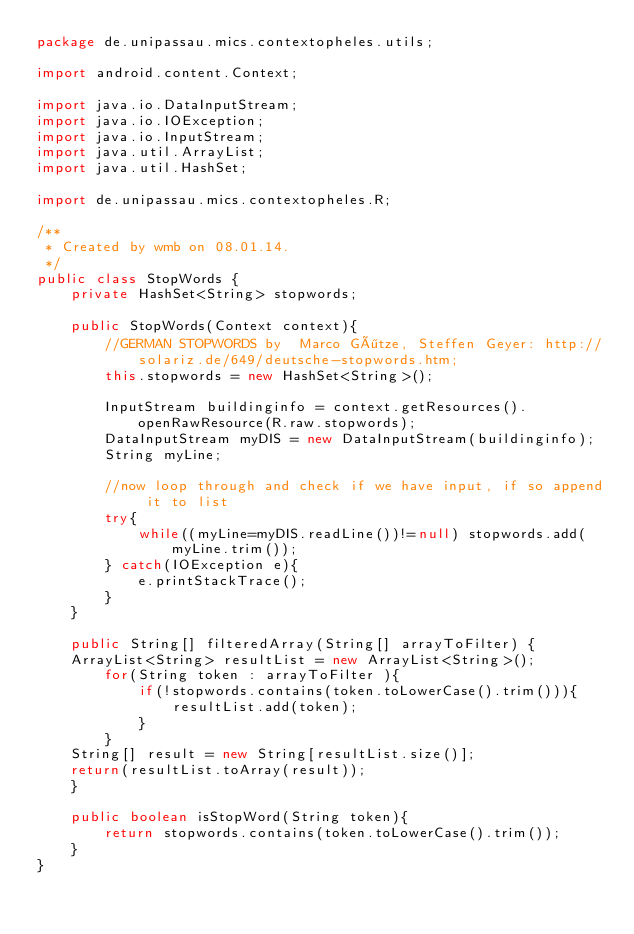<code> <loc_0><loc_0><loc_500><loc_500><_Java_>package de.unipassau.mics.contextopheles.utils;

import android.content.Context;

import java.io.DataInputStream;
import java.io.IOException;
import java.io.InputStream;
import java.util.ArrayList;
import java.util.HashSet;

import de.unipassau.mics.contextopheles.R;

/**
 * Created by wmb on 08.01.14.
 */
public class StopWords {
    private HashSet<String> stopwords;

    public StopWords(Context context){
        //GERMAN STOPWORDS by  Marco Götze, Steffen Geyer: http://solariz.de/649/deutsche-stopwords.htm;
        this.stopwords = new HashSet<String>();

        InputStream buildinginfo = context.getResources().openRawResource(R.raw.stopwords);
        DataInputStream myDIS = new DataInputStream(buildinginfo);
        String myLine;

        //now loop through and check if we have input, if so append it to list
        try{
            while((myLine=myDIS.readLine())!=null) stopwords.add(myLine.trim());
        } catch(IOException e){
            e.printStackTrace();
        }
    }

    public String[] filteredArray(String[] arrayToFilter) {
    ArrayList<String> resultList = new ArrayList<String>();
        for(String token : arrayToFilter ){
            if(!stopwords.contains(token.toLowerCase().trim())){
                resultList.add(token);
            }
        }
    String[] result = new String[resultList.size()];
    return(resultList.toArray(result));
    }

    public boolean isStopWord(String token){
        return stopwords.contains(token.toLowerCase().trim());
    }
}
</code> 